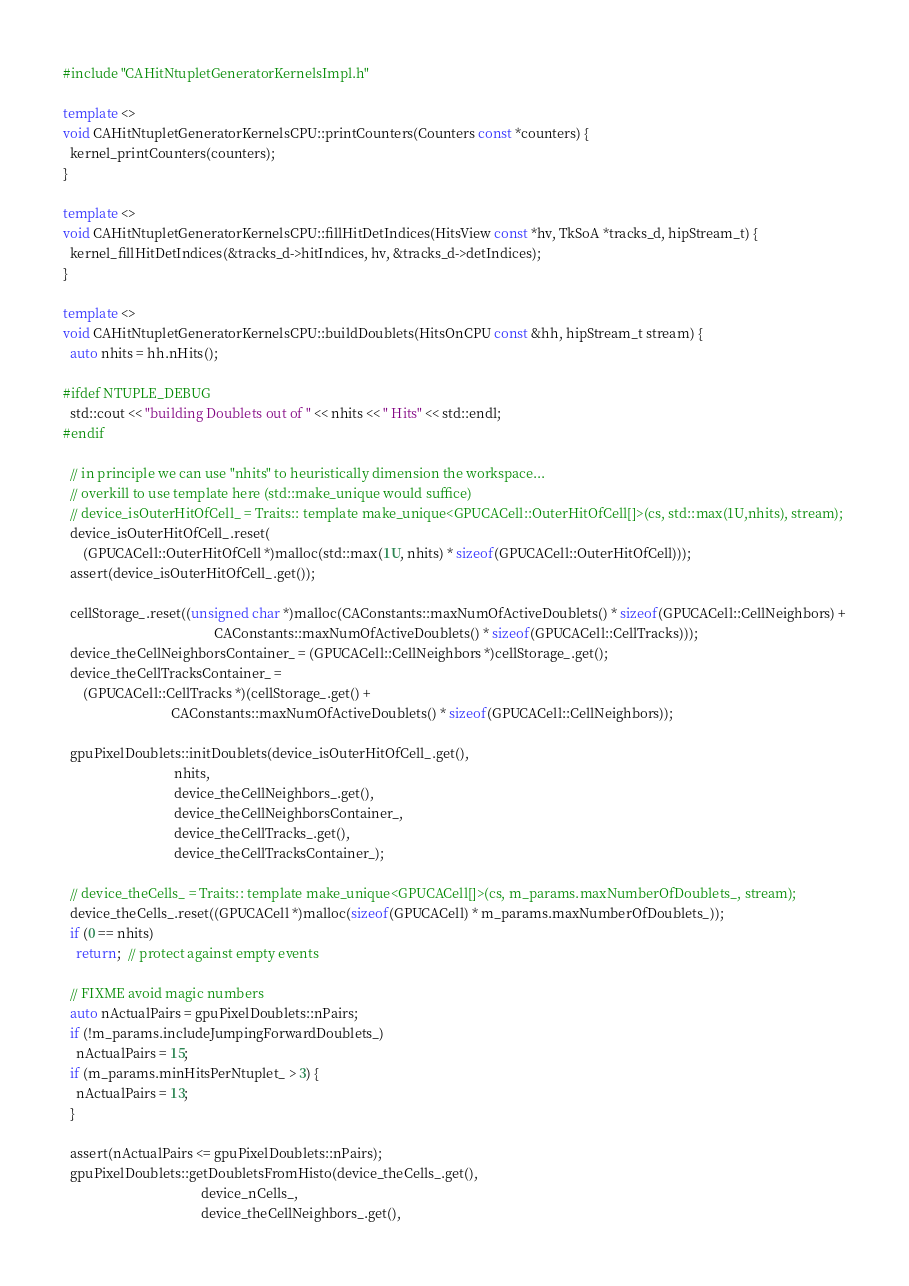Convert code to text. <code><loc_0><loc_0><loc_500><loc_500><_C++_>#include "CAHitNtupletGeneratorKernelsImpl.h"

template <>
void CAHitNtupletGeneratorKernelsCPU::printCounters(Counters const *counters) {
  kernel_printCounters(counters);
}

template <>
void CAHitNtupletGeneratorKernelsCPU::fillHitDetIndices(HitsView const *hv, TkSoA *tracks_d, hipStream_t) {
  kernel_fillHitDetIndices(&tracks_d->hitIndices, hv, &tracks_d->detIndices);
}

template <>
void CAHitNtupletGeneratorKernelsCPU::buildDoublets(HitsOnCPU const &hh, hipStream_t stream) {
  auto nhits = hh.nHits();

#ifdef NTUPLE_DEBUG
  std::cout << "building Doublets out of " << nhits << " Hits" << std::endl;
#endif

  // in principle we can use "nhits" to heuristically dimension the workspace...
  // overkill to use template here (std::make_unique would suffice)
  // device_isOuterHitOfCell_ = Traits:: template make_unique<GPUCACell::OuterHitOfCell[]>(cs, std::max(1U,nhits), stream);
  device_isOuterHitOfCell_.reset(
      (GPUCACell::OuterHitOfCell *)malloc(std::max(1U, nhits) * sizeof(GPUCACell::OuterHitOfCell)));
  assert(device_isOuterHitOfCell_.get());

  cellStorage_.reset((unsigned char *)malloc(CAConstants::maxNumOfActiveDoublets() * sizeof(GPUCACell::CellNeighbors) +
                                             CAConstants::maxNumOfActiveDoublets() * sizeof(GPUCACell::CellTracks)));
  device_theCellNeighborsContainer_ = (GPUCACell::CellNeighbors *)cellStorage_.get();
  device_theCellTracksContainer_ =
      (GPUCACell::CellTracks *)(cellStorage_.get() +
                                CAConstants::maxNumOfActiveDoublets() * sizeof(GPUCACell::CellNeighbors));

  gpuPixelDoublets::initDoublets(device_isOuterHitOfCell_.get(),
                                 nhits,
                                 device_theCellNeighbors_.get(),
                                 device_theCellNeighborsContainer_,
                                 device_theCellTracks_.get(),
                                 device_theCellTracksContainer_);

  // device_theCells_ = Traits:: template make_unique<GPUCACell[]>(cs, m_params.maxNumberOfDoublets_, stream);
  device_theCells_.reset((GPUCACell *)malloc(sizeof(GPUCACell) * m_params.maxNumberOfDoublets_));
  if (0 == nhits)
    return;  // protect against empty events

  // FIXME avoid magic numbers
  auto nActualPairs = gpuPixelDoublets::nPairs;
  if (!m_params.includeJumpingForwardDoublets_)
    nActualPairs = 15;
  if (m_params.minHitsPerNtuplet_ > 3) {
    nActualPairs = 13;
  }

  assert(nActualPairs <= gpuPixelDoublets::nPairs);
  gpuPixelDoublets::getDoubletsFromHisto(device_theCells_.get(),
                                         device_nCells_,
                                         device_theCellNeighbors_.get(),</code> 